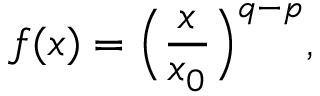<formula> <loc_0><loc_0><loc_500><loc_500>f ( x ) = \left ( \frac { x } { x _ { 0 } } \right ) ^ { q - p } ,</formula> 